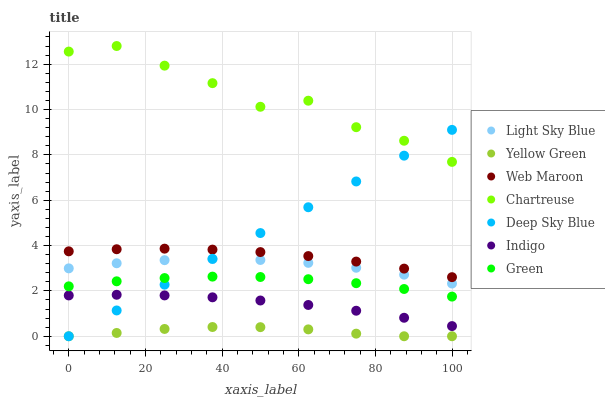Does Yellow Green have the minimum area under the curve?
Answer yes or no. Yes. Does Chartreuse have the maximum area under the curve?
Answer yes or no. Yes. Does Web Maroon have the minimum area under the curve?
Answer yes or no. No. Does Web Maroon have the maximum area under the curve?
Answer yes or no. No. Is Deep Sky Blue the smoothest?
Answer yes or no. Yes. Is Chartreuse the roughest?
Answer yes or no. Yes. Is Yellow Green the smoothest?
Answer yes or no. No. Is Yellow Green the roughest?
Answer yes or no. No. Does Yellow Green have the lowest value?
Answer yes or no. Yes. Does Web Maroon have the lowest value?
Answer yes or no. No. Does Chartreuse have the highest value?
Answer yes or no. Yes. Does Web Maroon have the highest value?
Answer yes or no. No. Is Indigo less than Web Maroon?
Answer yes or no. Yes. Is Web Maroon greater than Green?
Answer yes or no. Yes. Does Deep Sky Blue intersect Web Maroon?
Answer yes or no. Yes. Is Deep Sky Blue less than Web Maroon?
Answer yes or no. No. Is Deep Sky Blue greater than Web Maroon?
Answer yes or no. No. Does Indigo intersect Web Maroon?
Answer yes or no. No. 